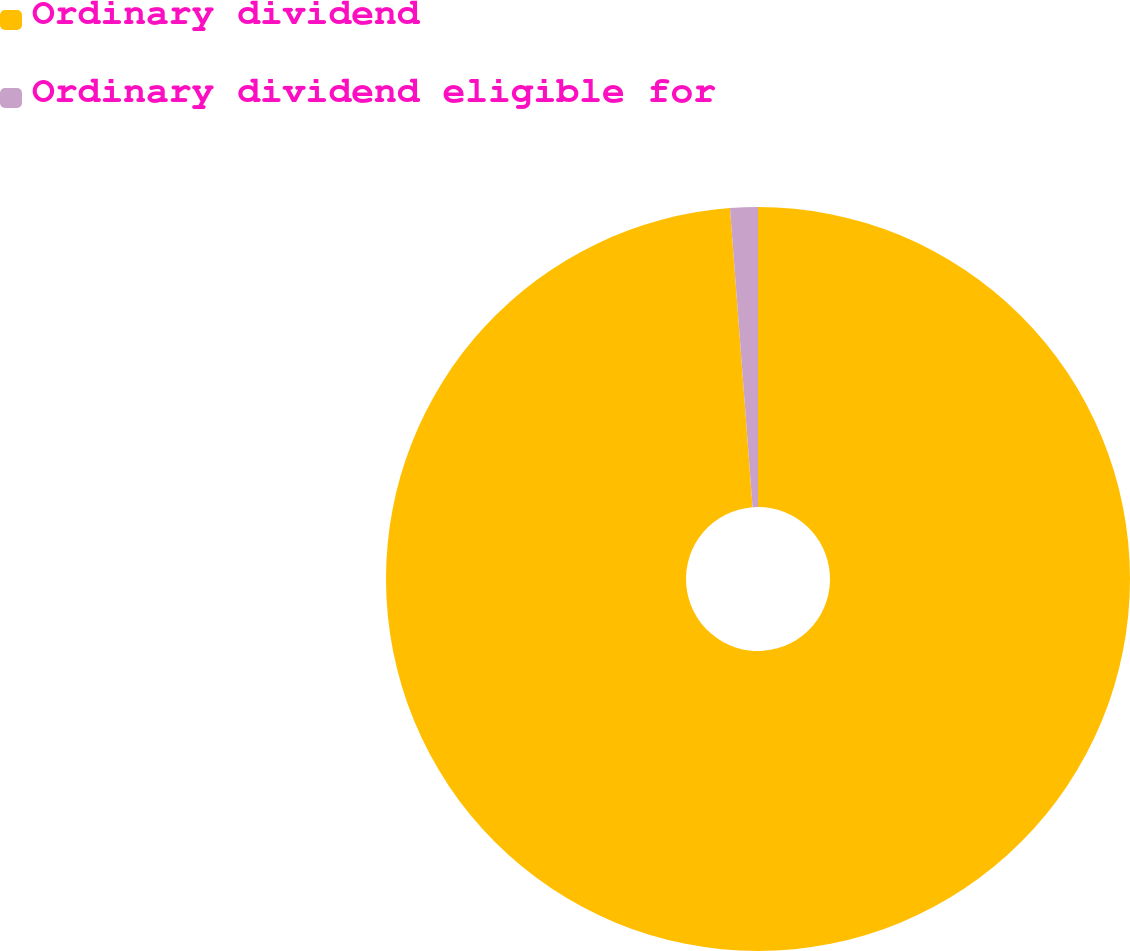Convert chart. <chart><loc_0><loc_0><loc_500><loc_500><pie_chart><fcel>Ordinary dividend<fcel>Ordinary dividend eligible for<nl><fcel>98.8%<fcel>1.2%<nl></chart> 